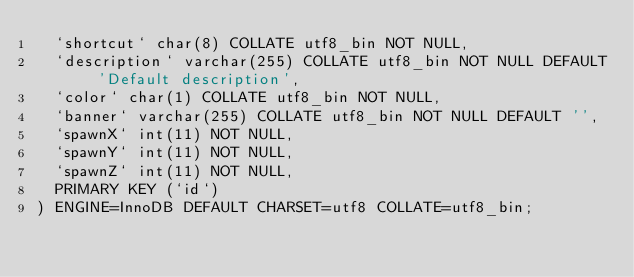<code> <loc_0><loc_0><loc_500><loc_500><_SQL_>  `shortcut` char(8) COLLATE utf8_bin NOT NULL,
  `description` varchar(255) COLLATE utf8_bin NOT NULL DEFAULT 'Default description',
  `color` char(1) COLLATE utf8_bin NOT NULL,
  `banner` varchar(255) COLLATE utf8_bin NOT NULL DEFAULT '',
  `spawnX` int(11) NOT NULL,
  `spawnY` int(11) NOT NULL,
  `spawnZ` int(11) NOT NULL,
  PRIMARY KEY (`id`)
) ENGINE=InnoDB DEFAULT CHARSET=utf8 COLLATE=utf8_bin;</code> 